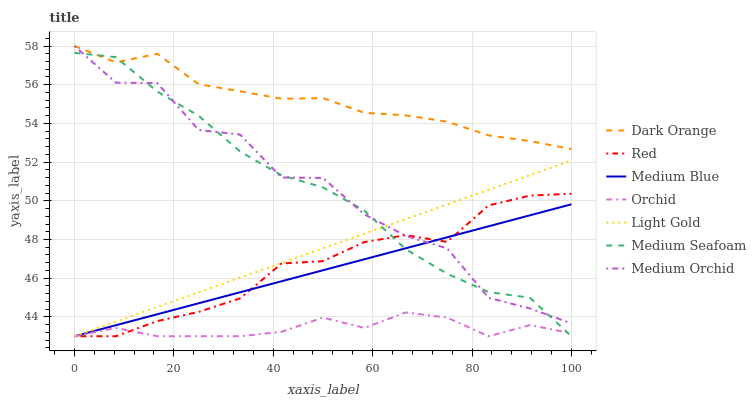Does Orchid have the minimum area under the curve?
Answer yes or no. Yes. Does Dark Orange have the maximum area under the curve?
Answer yes or no. Yes. Does Medium Orchid have the minimum area under the curve?
Answer yes or no. No. Does Medium Orchid have the maximum area under the curve?
Answer yes or no. No. Is Medium Blue the smoothest?
Answer yes or no. Yes. Is Medium Orchid the roughest?
Answer yes or no. Yes. Is Medium Orchid the smoothest?
Answer yes or no. No. Is Medium Blue the roughest?
Answer yes or no. No. Does Medium Blue have the lowest value?
Answer yes or no. Yes. Does Medium Orchid have the lowest value?
Answer yes or no. No. Does Medium Orchid have the highest value?
Answer yes or no. Yes. Does Medium Blue have the highest value?
Answer yes or no. No. Is Medium Blue less than Dark Orange?
Answer yes or no. Yes. Is Dark Orange greater than Orchid?
Answer yes or no. Yes. Does Medium Orchid intersect Dark Orange?
Answer yes or no. Yes. Is Medium Orchid less than Dark Orange?
Answer yes or no. No. Is Medium Orchid greater than Dark Orange?
Answer yes or no. No. Does Medium Blue intersect Dark Orange?
Answer yes or no. No. 